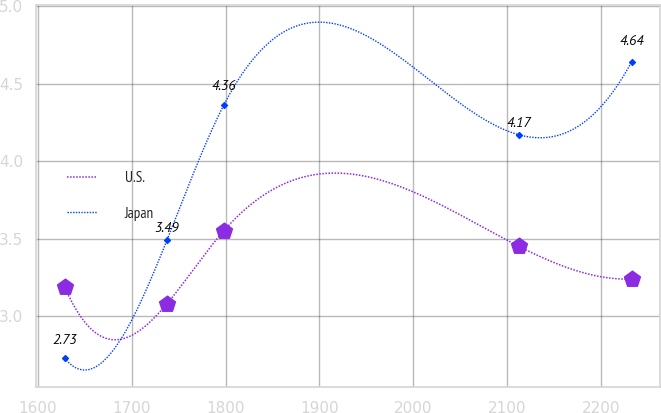Convert chart to OTSL. <chart><loc_0><loc_0><loc_500><loc_500><line_chart><ecel><fcel>U.S.<fcel>Japan<nl><fcel>1628.48<fcel>3.19<fcel>2.73<nl><fcel>1737.53<fcel>3.08<fcel>3.49<nl><fcel>1797.94<fcel>3.55<fcel>4.36<nl><fcel>2112.95<fcel>3.45<fcel>4.17<nl><fcel>2232.61<fcel>3.24<fcel>4.64<nl></chart> 